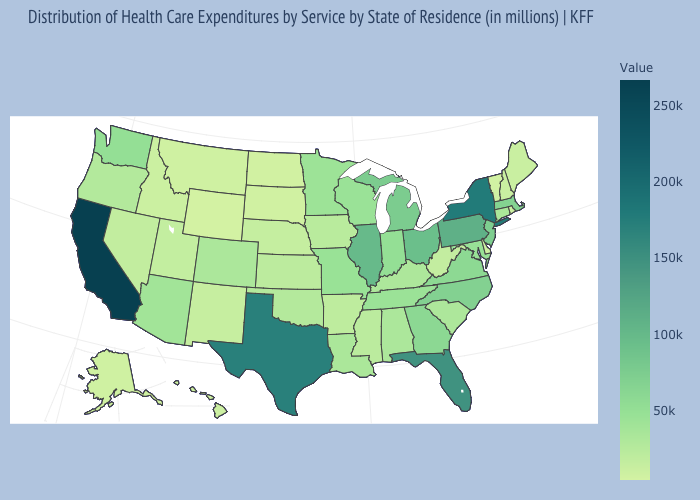Does Illinois have the highest value in the MidWest?
Short answer required. Yes. Among the states that border Minnesota , which have the highest value?
Short answer required. Wisconsin. Does Colorado have the lowest value in the West?
Keep it brief. No. Among the states that border Utah , which have the highest value?
Answer briefly. Arizona. Among the states that border Arkansas , does Mississippi have the lowest value?
Quick response, please. Yes. 